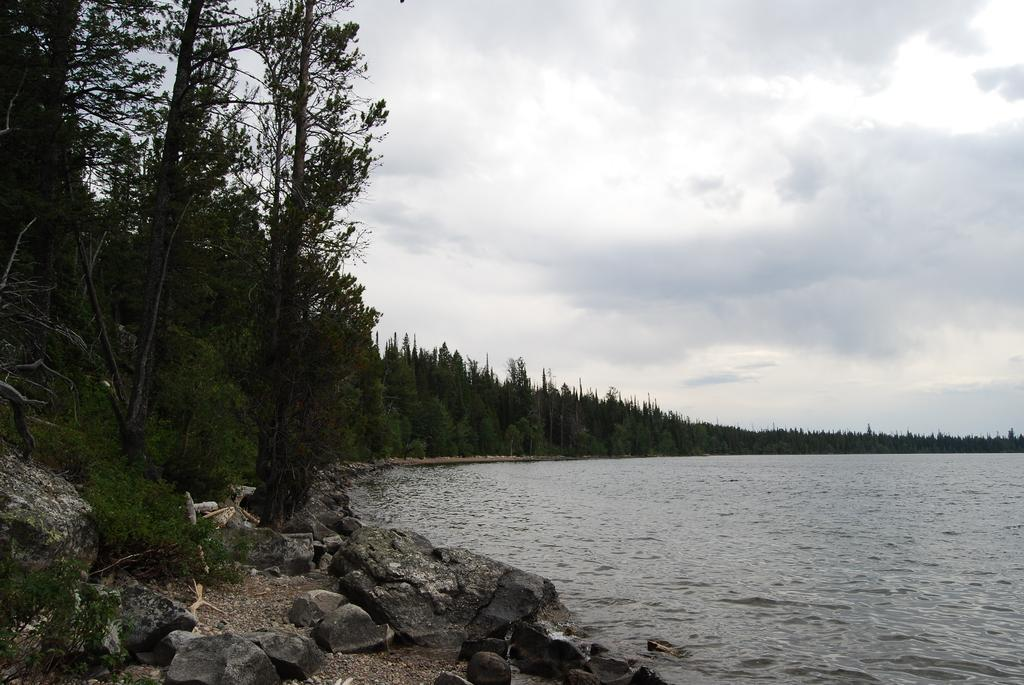What type of body of water is on the right side of the image? There is a lake on the right side of the image. What surrounds the lake in the image? There are trees around the lake. What can be seen at the bottom of the image? There are stones at the bottom of the image. What is visible at the top of the image? The sky is visible at the top of the image. Can you tell me what the writer is doing in the image? There is no writer present in the image; it features a lake surrounded by trees, stones, and a visible sky. 